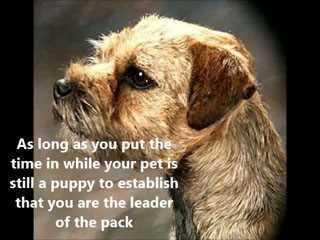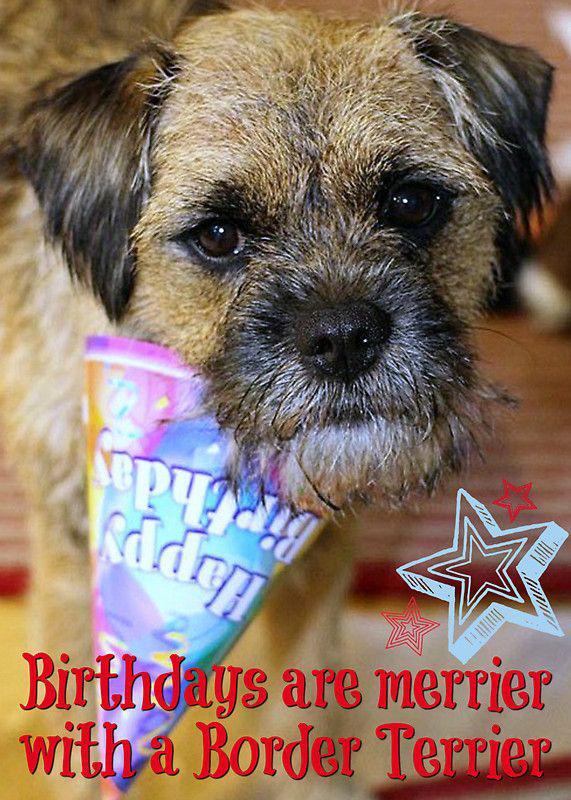The first image is the image on the left, the second image is the image on the right. Examine the images to the left and right. Is the description "the dog is laying down on the right side pic" accurate? Answer yes or no. No. 